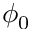Convert formula to latex. <formula><loc_0><loc_0><loc_500><loc_500>\phi _ { 0 }</formula> 